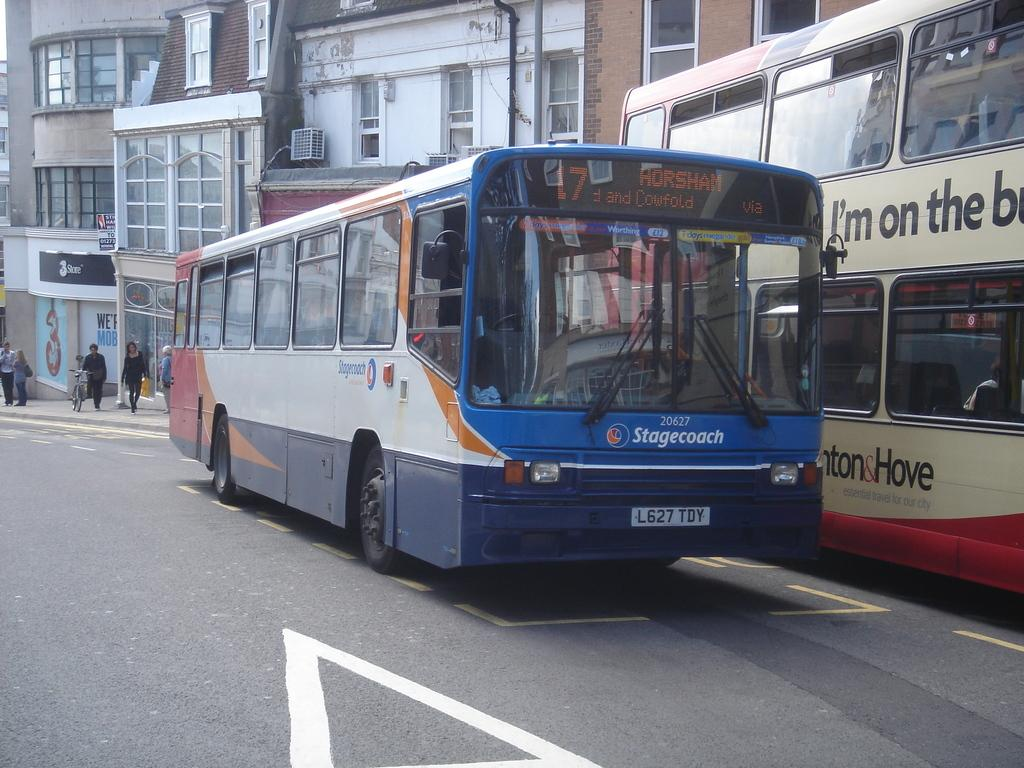<image>
Render a clear and concise summary of the photo. A Stagecoach bus with the license plate L627 TDY driving to Horsham is on the street. 